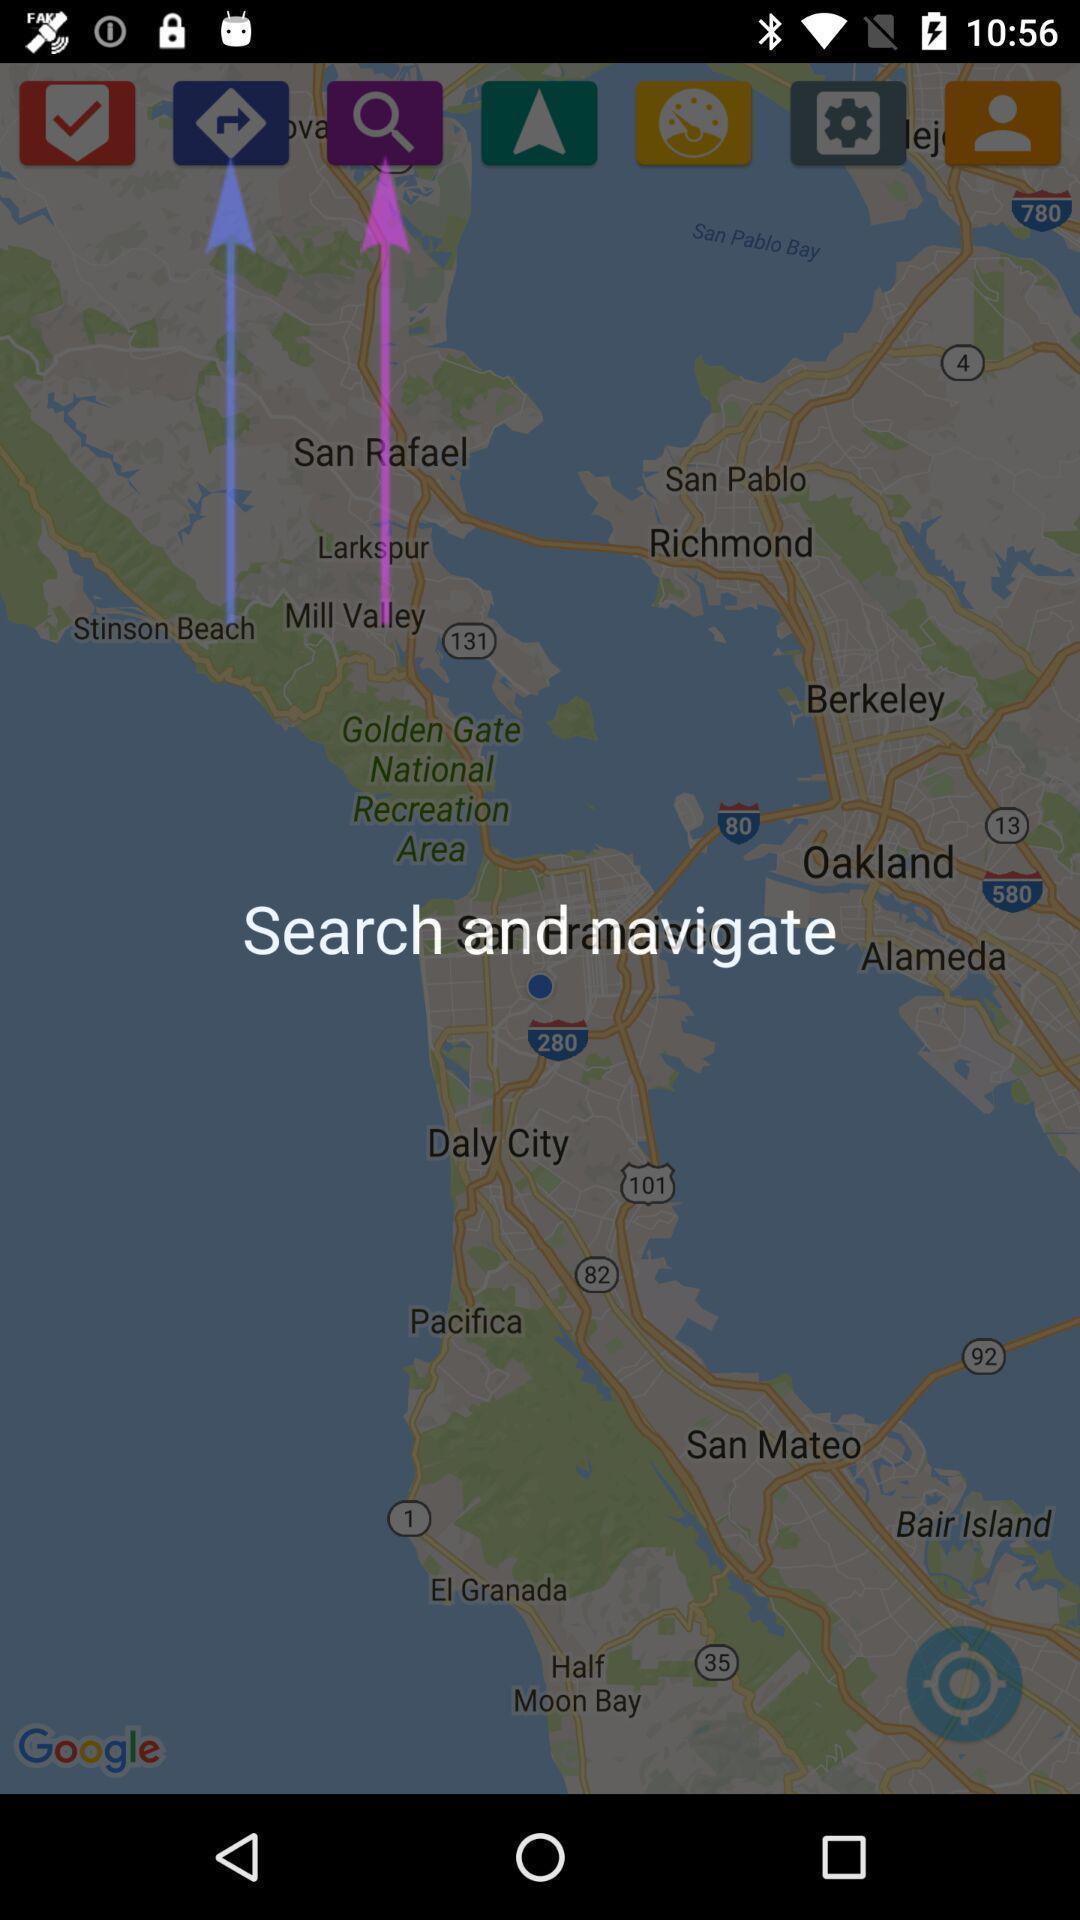Tell me what you see in this picture. Screen displaying various tools in app. 